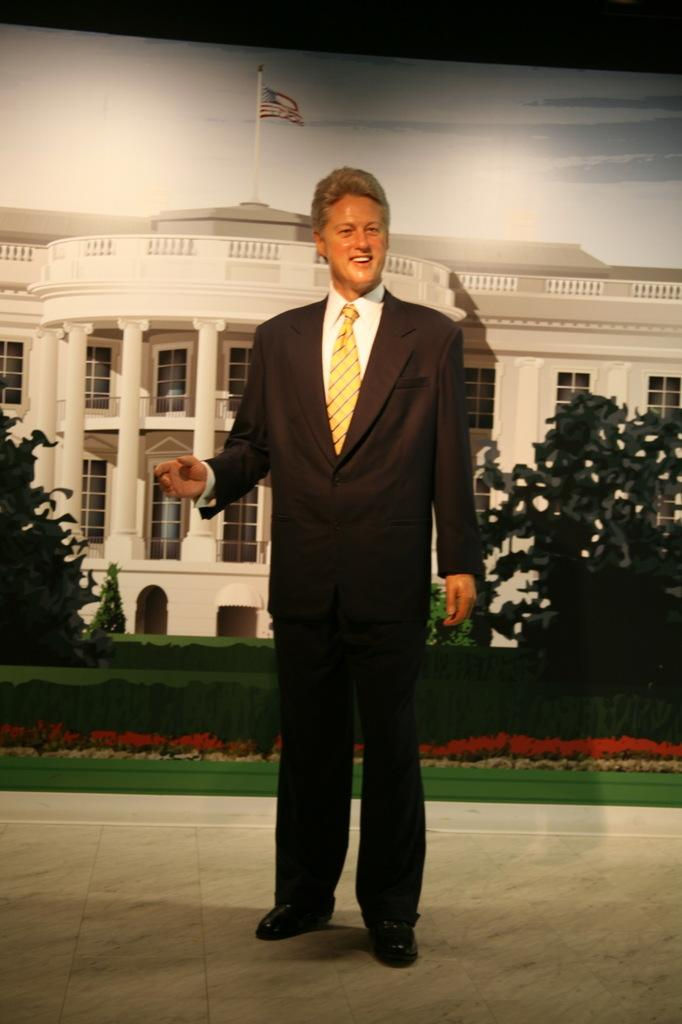What is the main subject of the image? There is a statue of a man in the image. How is the man depicted in the statue? The statue depicts the man as standing and smiling. What can be seen in the background of the image? There is a poster, trees, plants, a flag, and the sky visible in the background of the image. What is featured on the poster? The poster features a building. What type of steel is used to construct the drawer in the image? There is no drawer present in the image, so it is not possible to determine the type of steel used in its construction. 